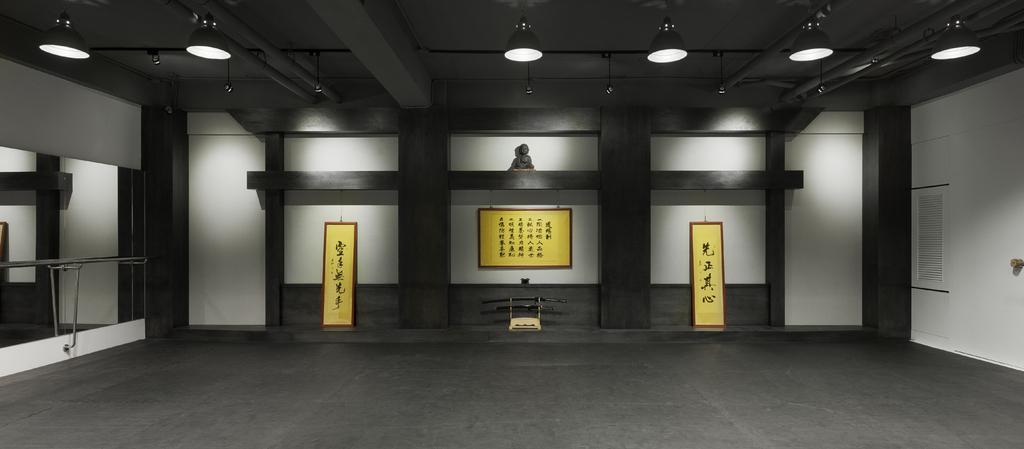How would you summarize this image in a sentence or two? This picture is clicked inside the room or a hall. Here, we see three yellow boards with text written is placed on the white wall. Above that, we see a statue. On the right side, we see a white board with text written on it, is placed on the white wall. On the left side, we see a glass door. At the top of the picture, we see the ceiling of the room. 